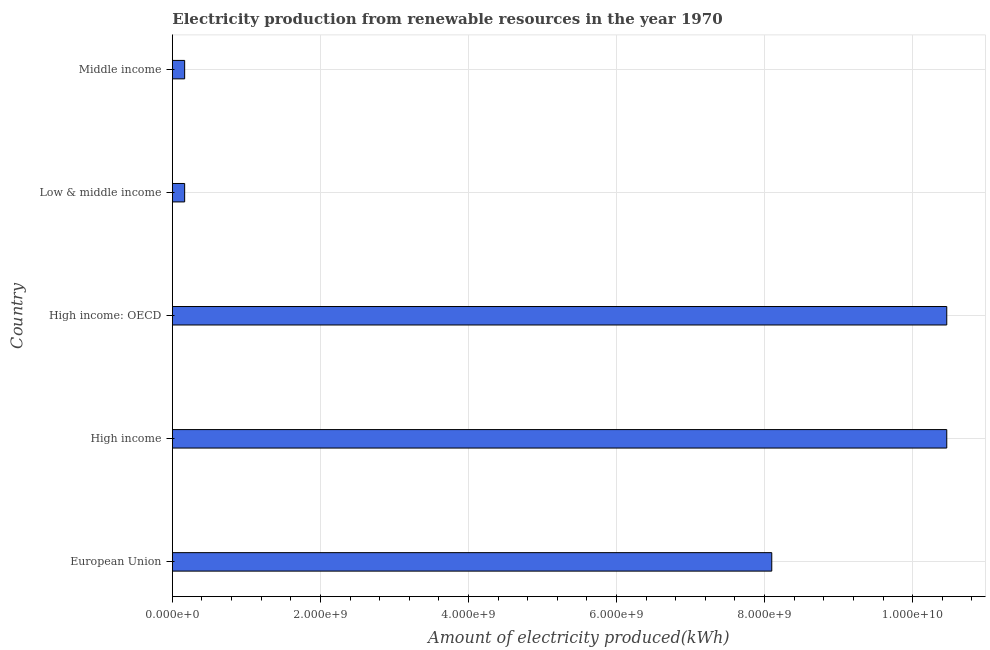Does the graph contain any zero values?
Your answer should be compact. No. What is the title of the graph?
Give a very brief answer. Electricity production from renewable resources in the year 1970. What is the label or title of the X-axis?
Offer a terse response. Amount of electricity produced(kWh). What is the amount of electricity produced in Middle income?
Your answer should be very brief. 1.66e+08. Across all countries, what is the maximum amount of electricity produced?
Keep it short and to the point. 1.05e+1. Across all countries, what is the minimum amount of electricity produced?
Your answer should be very brief. 1.66e+08. In which country was the amount of electricity produced maximum?
Keep it short and to the point. High income. In which country was the amount of electricity produced minimum?
Provide a succinct answer. Low & middle income. What is the sum of the amount of electricity produced?
Your answer should be very brief. 2.94e+1. What is the difference between the amount of electricity produced in High income and High income: OECD?
Offer a terse response. 0. What is the average amount of electricity produced per country?
Make the answer very short. 5.87e+09. What is the median amount of electricity produced?
Make the answer very short. 8.10e+09. What is the ratio of the amount of electricity produced in High income to that in Middle income?
Ensure brevity in your answer.  63.02. Is the amount of electricity produced in High income less than that in Middle income?
Provide a succinct answer. No. Is the sum of the amount of electricity produced in High income and Low & middle income greater than the maximum amount of electricity produced across all countries?
Your answer should be compact. Yes. What is the difference between the highest and the lowest amount of electricity produced?
Make the answer very short. 1.03e+1. How many bars are there?
Provide a short and direct response. 5. Are all the bars in the graph horizontal?
Offer a very short reply. Yes. How many countries are there in the graph?
Make the answer very short. 5. What is the difference between two consecutive major ticks on the X-axis?
Offer a very short reply. 2.00e+09. What is the Amount of electricity produced(kWh) in European Union?
Your response must be concise. 8.10e+09. What is the Amount of electricity produced(kWh) of High income?
Your answer should be very brief. 1.05e+1. What is the Amount of electricity produced(kWh) in High income: OECD?
Your response must be concise. 1.05e+1. What is the Amount of electricity produced(kWh) in Low & middle income?
Your response must be concise. 1.66e+08. What is the Amount of electricity produced(kWh) in Middle income?
Offer a very short reply. 1.66e+08. What is the difference between the Amount of electricity produced(kWh) in European Union and High income?
Ensure brevity in your answer.  -2.36e+09. What is the difference between the Amount of electricity produced(kWh) in European Union and High income: OECD?
Your answer should be compact. -2.36e+09. What is the difference between the Amount of electricity produced(kWh) in European Union and Low & middle income?
Your response must be concise. 7.93e+09. What is the difference between the Amount of electricity produced(kWh) in European Union and Middle income?
Make the answer very short. 7.93e+09. What is the difference between the Amount of electricity produced(kWh) in High income and High income: OECD?
Make the answer very short. 0. What is the difference between the Amount of electricity produced(kWh) in High income and Low & middle income?
Ensure brevity in your answer.  1.03e+1. What is the difference between the Amount of electricity produced(kWh) in High income and Middle income?
Offer a terse response. 1.03e+1. What is the difference between the Amount of electricity produced(kWh) in High income: OECD and Low & middle income?
Your response must be concise. 1.03e+1. What is the difference between the Amount of electricity produced(kWh) in High income: OECD and Middle income?
Your answer should be very brief. 1.03e+1. What is the difference between the Amount of electricity produced(kWh) in Low & middle income and Middle income?
Your answer should be compact. 0. What is the ratio of the Amount of electricity produced(kWh) in European Union to that in High income?
Your answer should be very brief. 0.77. What is the ratio of the Amount of electricity produced(kWh) in European Union to that in High income: OECD?
Make the answer very short. 0.77. What is the ratio of the Amount of electricity produced(kWh) in European Union to that in Low & middle income?
Your response must be concise. 48.78. What is the ratio of the Amount of electricity produced(kWh) in European Union to that in Middle income?
Offer a very short reply. 48.78. What is the ratio of the Amount of electricity produced(kWh) in High income to that in High income: OECD?
Ensure brevity in your answer.  1. What is the ratio of the Amount of electricity produced(kWh) in High income to that in Low & middle income?
Ensure brevity in your answer.  63.02. What is the ratio of the Amount of electricity produced(kWh) in High income to that in Middle income?
Your response must be concise. 63.02. What is the ratio of the Amount of electricity produced(kWh) in High income: OECD to that in Low & middle income?
Make the answer very short. 63.02. What is the ratio of the Amount of electricity produced(kWh) in High income: OECD to that in Middle income?
Your response must be concise. 63.02. What is the ratio of the Amount of electricity produced(kWh) in Low & middle income to that in Middle income?
Offer a very short reply. 1. 